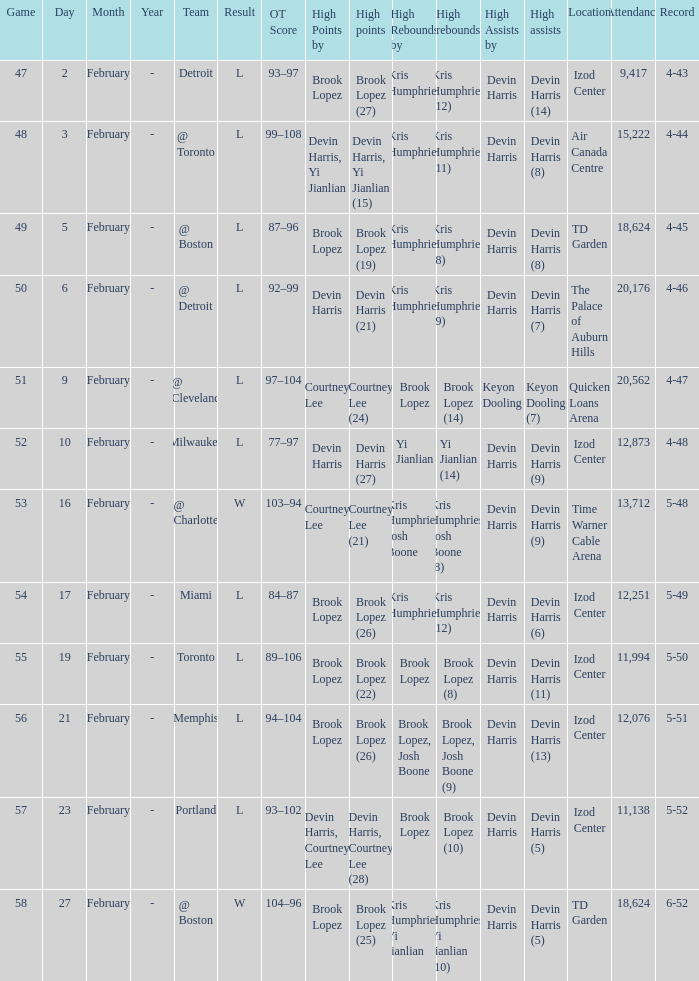What was the score of the game in which Brook Lopez (8) did the high rebounds? L 89–106 (OT). 